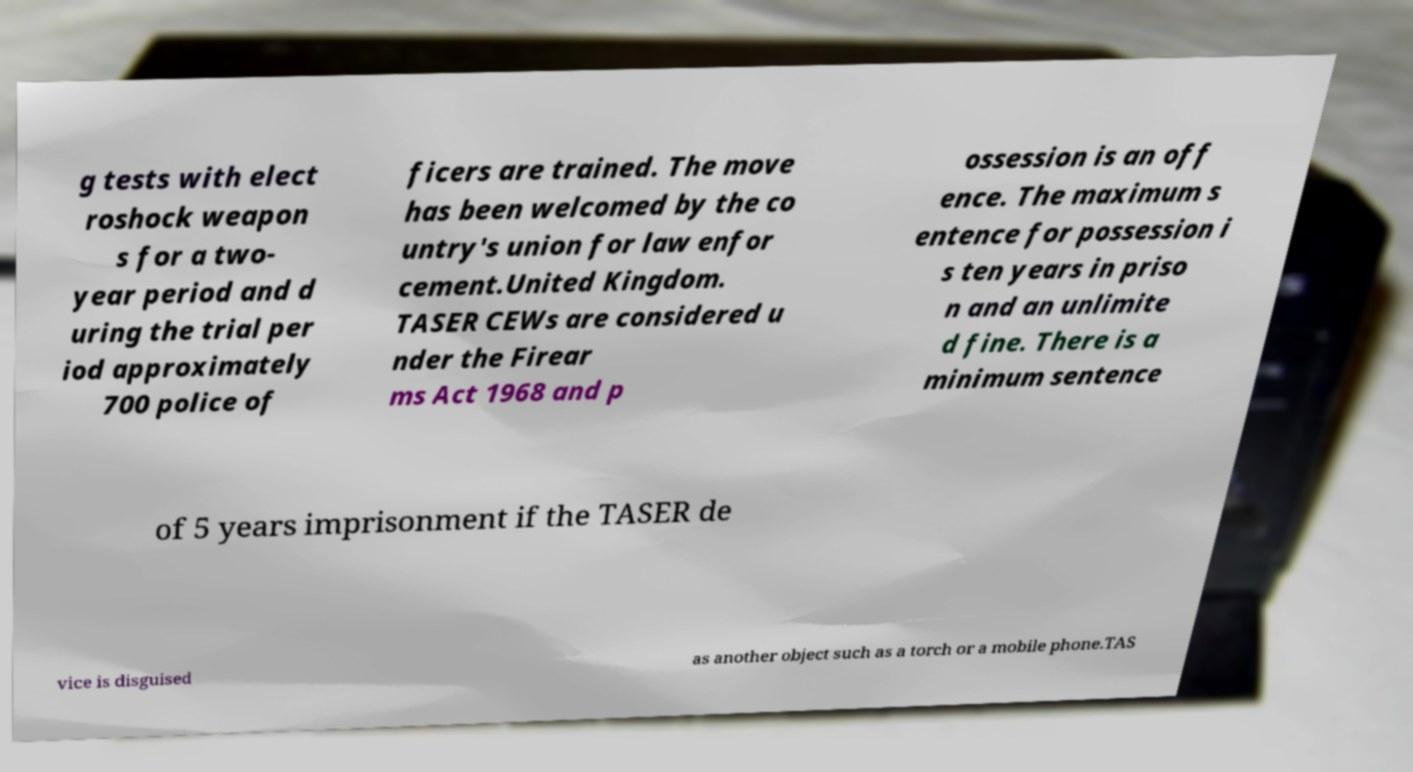Could you assist in decoding the text presented in this image and type it out clearly? g tests with elect roshock weapon s for a two- year period and d uring the trial per iod approximately 700 police of ficers are trained. The move has been welcomed by the co untry's union for law enfor cement.United Kingdom. TASER CEWs are considered u nder the Firear ms Act 1968 and p ossession is an off ence. The maximum s entence for possession i s ten years in priso n and an unlimite d fine. There is a minimum sentence of 5 years imprisonment if the TASER de vice is disguised as another object such as a torch or a mobile phone.TAS 